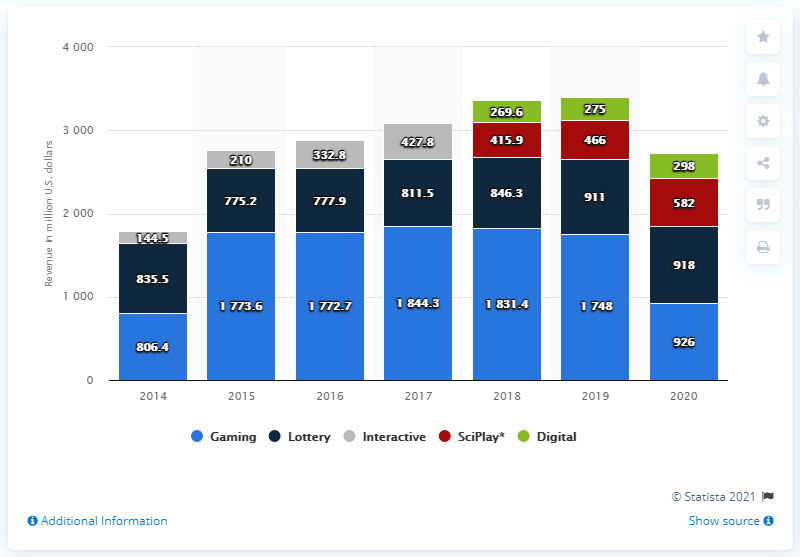Highlight a few significant elements in this photo. The gaming segment of Scientific Games Corporation's revenue during the 2020 financial year was approximately $926 million. 